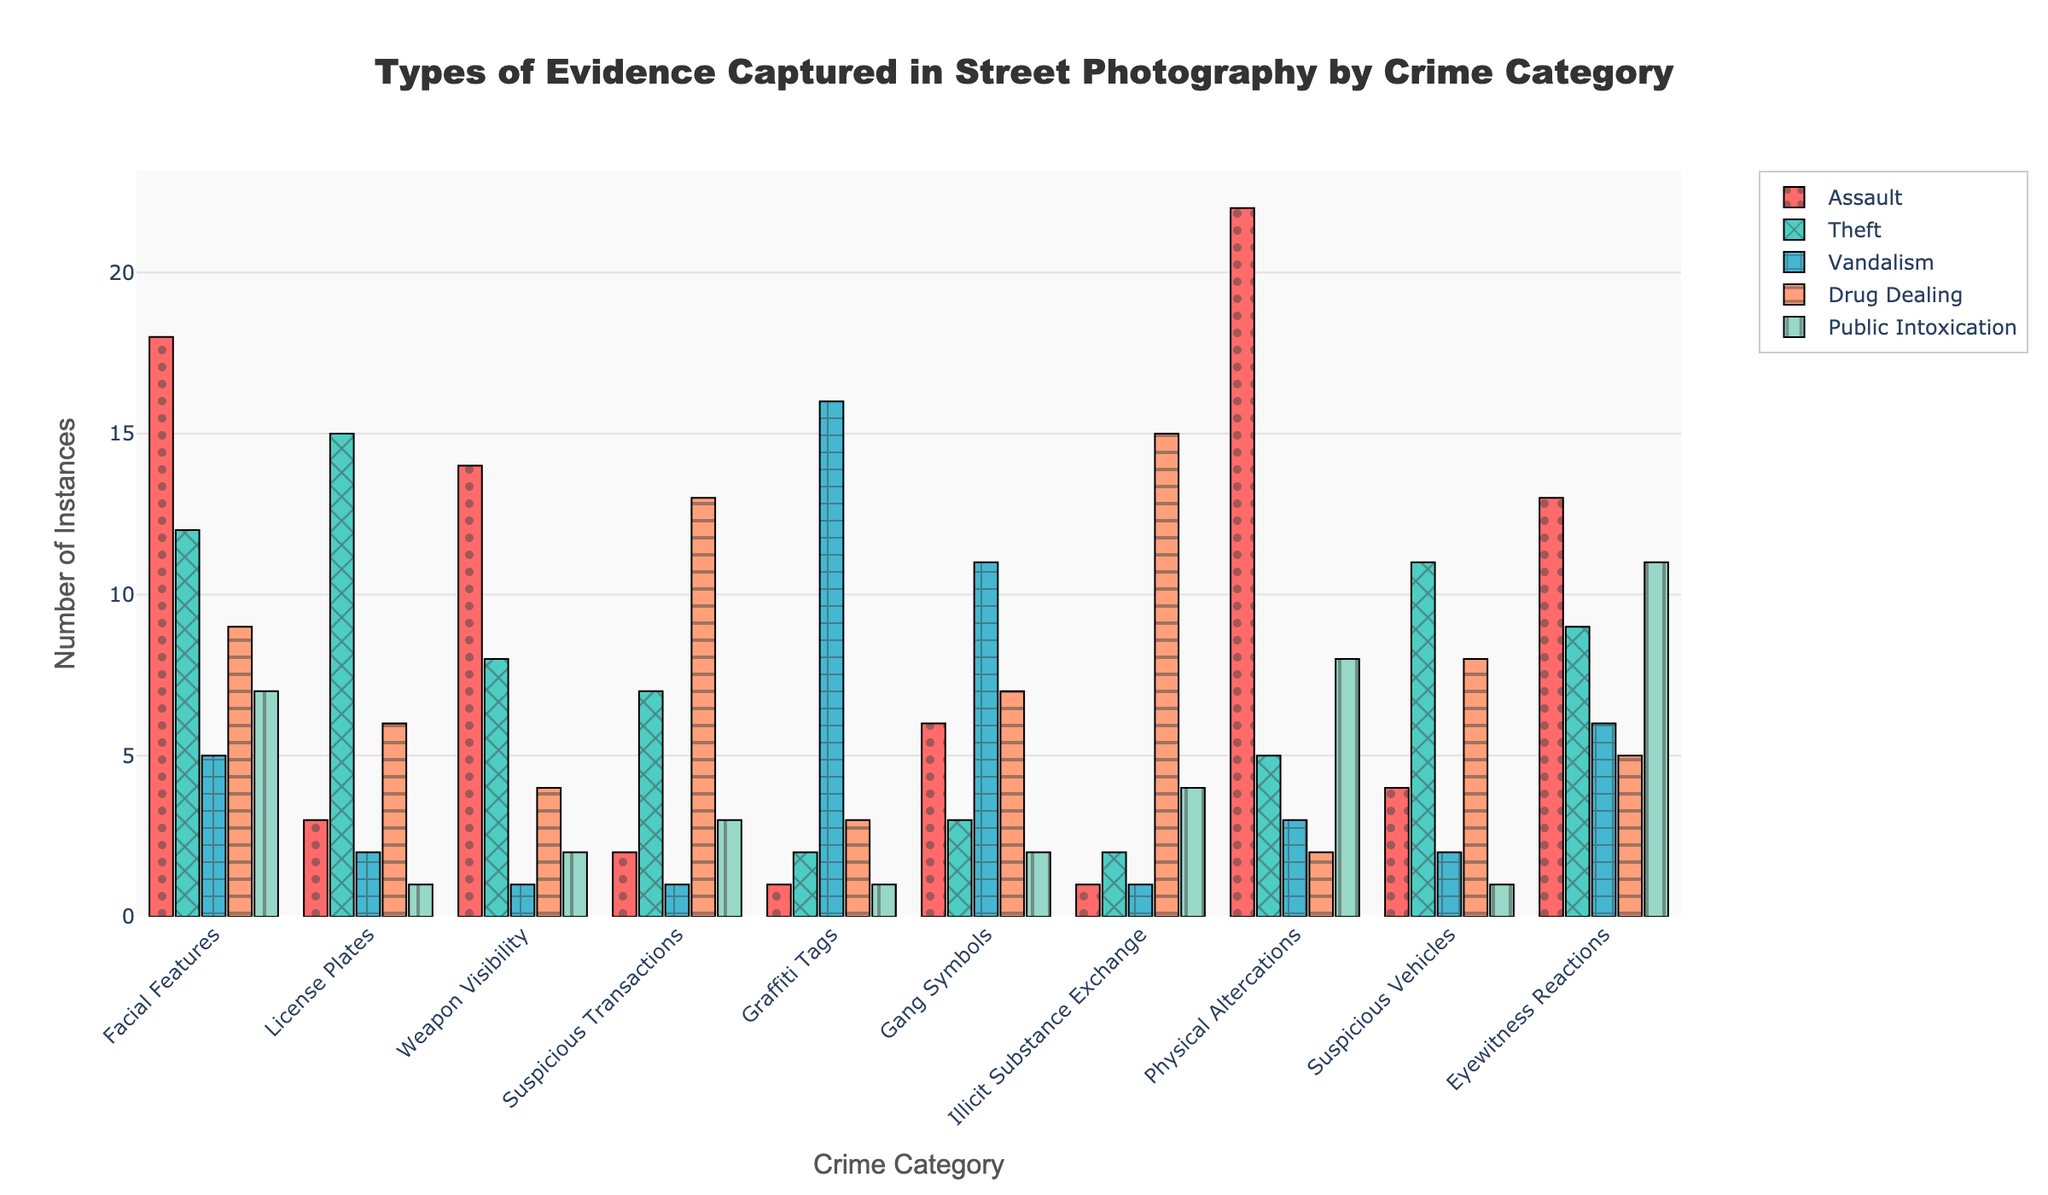Which crime category has the highest number of instances of facial features captured? The bar representing Assault for Facial Features is the tallest among all bars associated with Facial Features.
Answer: Assault How many more instances of physical altercations are captured in Assault compared to Drug Dealing? For Assault, there are 22 instances of Physical Altercations, and for Drug Dealing, there are 2. So, the difference is 22 - 2 = 20.
Answer: 20 Which type of evidence tied with Vandalism has the highest capture rate? The highest bar for Vandalism is Graffiti Tags, which is the tallest among all its evidence types.
Answer: Graffiti Tags Add the number of instances of suspicious transactions in Theft and Drug Dealing. Theft has 7 instances, and Drug Dealing has 13. Adding them gives 7 + 13 = 20.
Answer: 20 Is the height of the bar for illicit substance exchange in Drug Dealing greater than the height of the bar for weapon visibility in Assault? The bar for Illicit Substance Exchange in Drug Dealing (15) is smaller than the bar for Weapon Visibility in Assault (14).
Answer: No Which evidence type and crime category combination has the lowest number of instances? The lowest number of instances (1) are for Facial Features in Vandalism and Graffiti Tags in Assault, Theft, and Public Intoxication, and Illicit Substance Exchange in Assault, Vandalism, and Theft.
Answer: Multiple combinations with 1 instance Compare the number of instances of eyewitness reactions in Public Intoxication vs. Theft. Public Intoxication has 11 instances, while Theft has 9 instances, so Public Intoxication has 2 more instances than Theft.
Answer: Public Intoxication has 2 more Which has fewer captured instances among license plates in Vandalism and gang symbols in Public Intoxication? License Plates in Vandalism has 2 instances, while Gang Symbols in Public Intoxication has 2, making them equal.
Answer: They are equal Calculate the total number of instances of gang symbols across all categories. Summing the instances of Gang Symbols across all crime categories: 6 (Assault) + 3 (Theft) + 11 (Vandalism) + 7 (Drug Dealing) + 2 (Public Intoxication) = 29.
Answer: 29 Which type of evidence has the most instances captured in Drug Dealing? The bar for Illicit Substance Exchange is the tallest among all evidence types in Drug Dealing with 15 instances.
Answer: Illicit Substance Exchange 